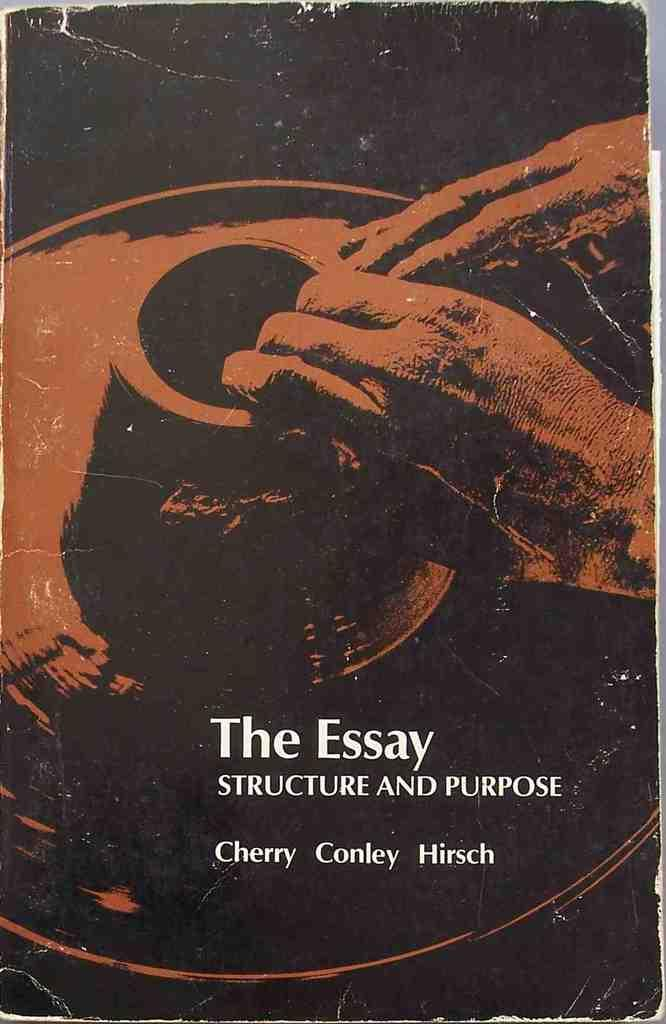<image>
Share a concise interpretation of the image provided. A book cover titled The Essay Structure and Purpose. 